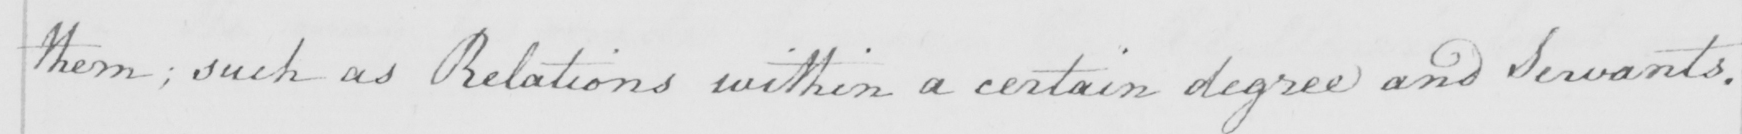Please provide the text content of this handwritten line. them ; such as Relations within a certain degree and Servants . 